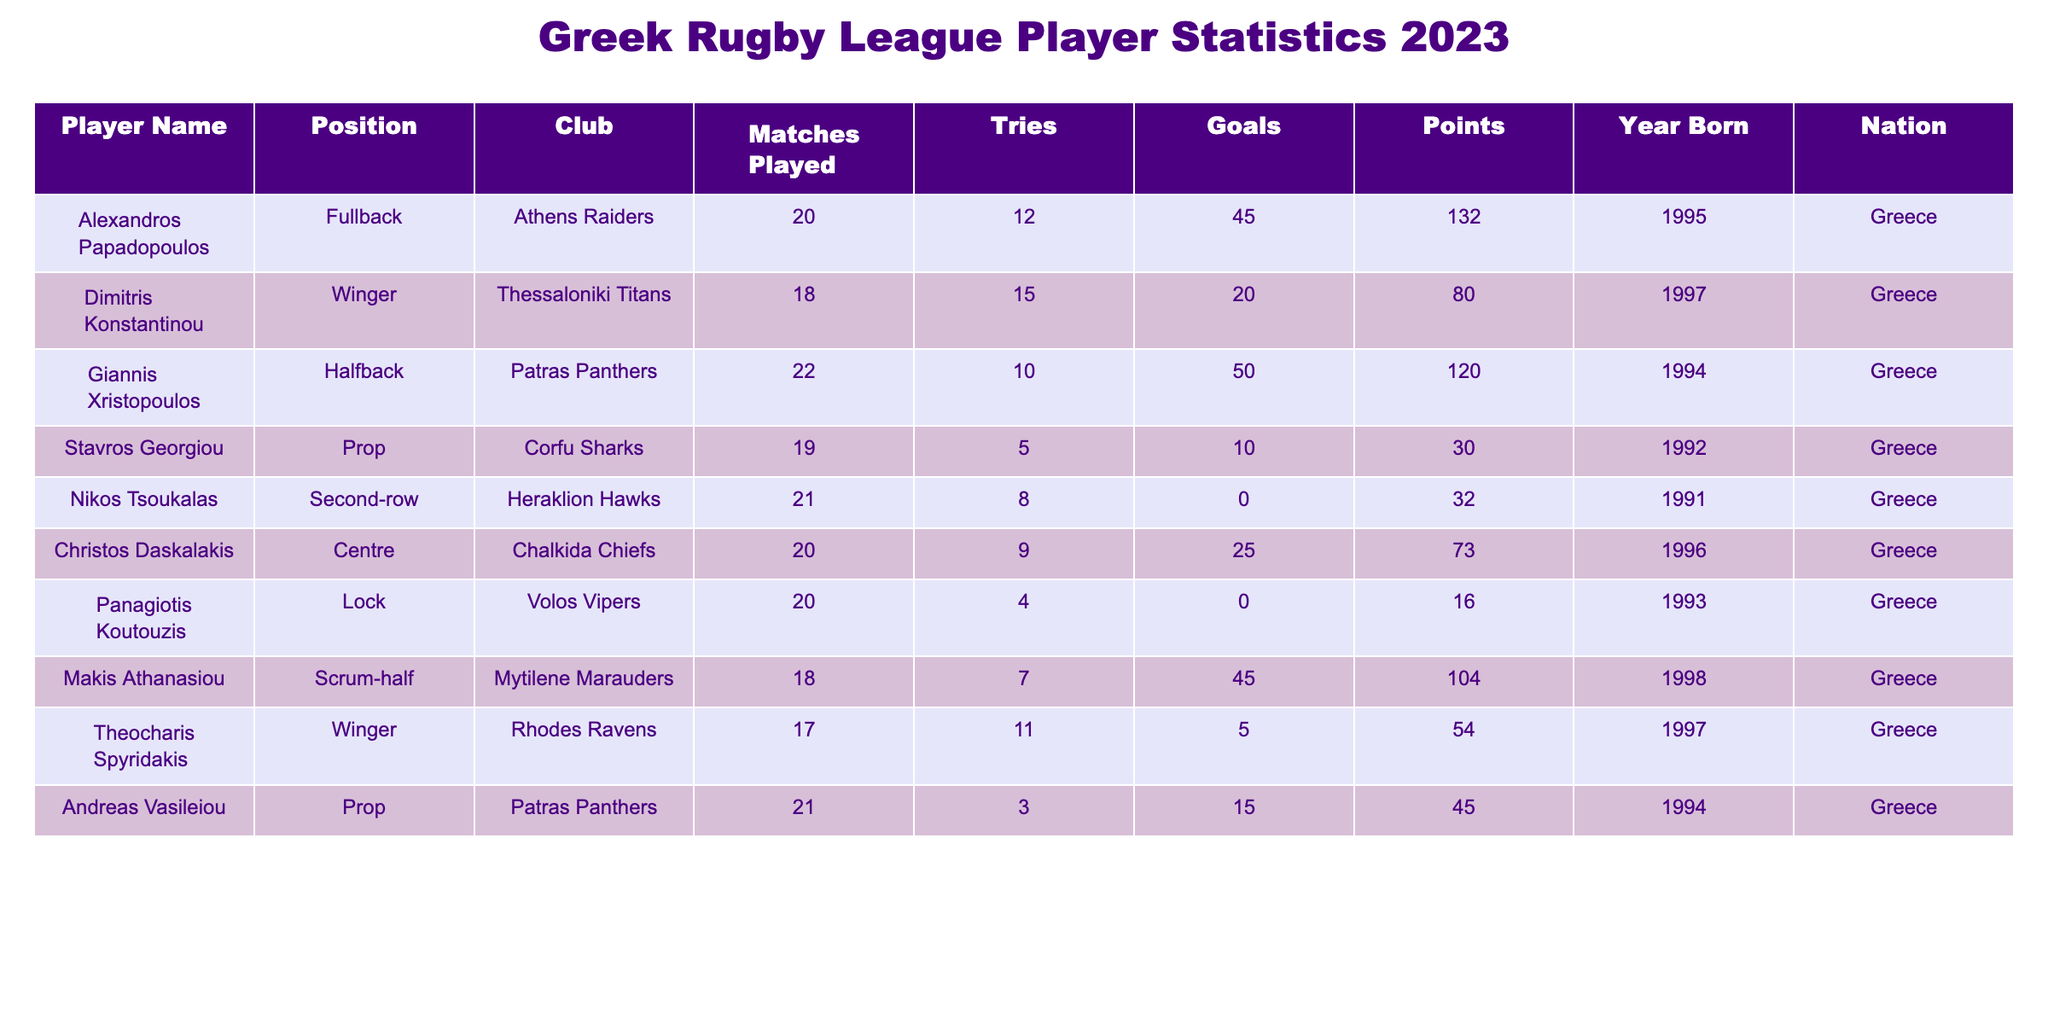What is the total number of tries scored by all players? To find the total number of tries, we add the tries scored by each player: 12 + 15 + 10 + 5 + 8 + 9 + 4 + 7 + 11 = 81.
Answer: 81 Who scored the highest number of points in the league? Checking the points column, Alexandros Papadopoulos has the highest points with 132.
Answer: Alexandros Papadopoulos How many players were born in Greece? All players in the table have the nationality listed as Greece; therefore, the count equals the total number of players, which is 9.
Answer: 9 What is the average number of matches played by the players? Add the matches played: 20 + 18 + 22 + 19 + 21 + 20 + 20 + 18 + 17 = 175. There are 9 players, so the average is 175 / 9 ≈ 19.44.
Answer: Approximately 19.44 Did the player Nikos Tsoukalas score any goals? According to the table, Nikos Tsoukalas has 0 goals scored.
Answer: No Which player has the highest number of goals and how many? Reviewing the goals scored, Giannis Xristopoulos has the highest number of goals at 50.
Answer: Giannis Xristopoulos, 50 What is the combined points of players from the Athens Raiders and Thessaloniki Titans? From the table, Alexandros Papadopoulos (Athens Raiders) has 132 points and Dimitris Konstantinou (Thessaloniki Titans) has 80 points. Combining these gives 132 + 80 = 212.
Answer: 212 Which position has the player with the fewest tries? The player with the fewest tries is Panagiotis Koutouzis, who plays in the Lock position with 4 tries.
Answer: Lock What is the difference in tries scored between the player with the most tries and the player with the least tries? The player with the most tries is Dimitris Konstantinou with 15 tries, and the player with the least is Panagiotis Koutouzis with 4 tries. The difference is 15 - 4 = 11.
Answer: 11 